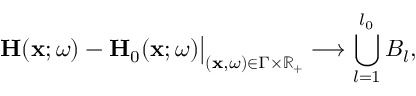Convert formula to latex. <formula><loc_0><loc_0><loc_500><loc_500>H ( x ; \omega ) - H _ { 0 } ( x ; \omega ) \Big | _ { ( x , \omega ) \in \Gamma \times \mathbb { R } _ { + } } \longrightarrow \bigcup _ { l = 1 } ^ { l _ { 0 } } B _ { l } ,</formula> 